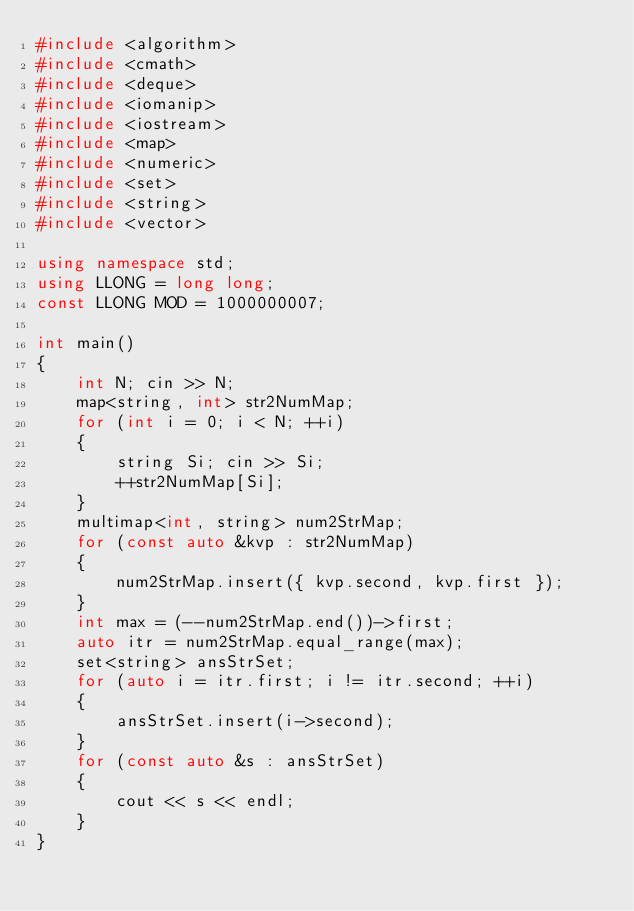Convert code to text. <code><loc_0><loc_0><loc_500><loc_500><_C++_>#include <algorithm>
#include <cmath>
#include <deque>
#include <iomanip>
#include <iostream>
#include <map>
#include <numeric>
#include <set>
#include <string>
#include <vector>

using namespace std;
using LLONG = long long;
const LLONG MOD = 1000000007;

int main()
{
    int N; cin >> N;
    map<string, int> str2NumMap;
    for (int i = 0; i < N; ++i)
    {
        string Si; cin >> Si;
        ++str2NumMap[Si];
    }
    multimap<int, string> num2StrMap;
    for (const auto &kvp : str2NumMap)
    {
        num2StrMap.insert({ kvp.second, kvp.first });
    }
    int max = (--num2StrMap.end())->first;
    auto itr = num2StrMap.equal_range(max);
    set<string> ansStrSet;
    for (auto i = itr.first; i != itr.second; ++i)
    {
        ansStrSet.insert(i->second);
    }
    for (const auto &s : ansStrSet)
    {
        cout << s << endl;
    }
}
</code> 